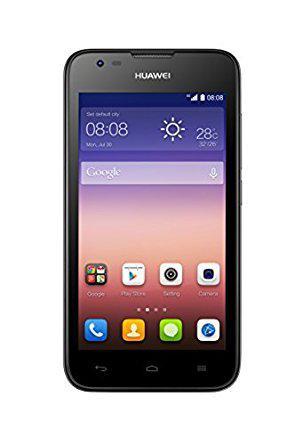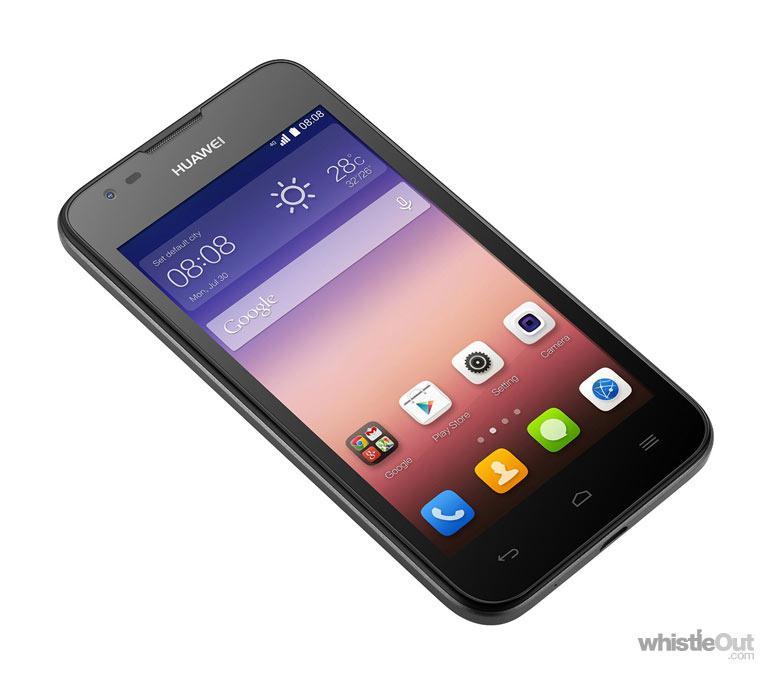The first image is the image on the left, the second image is the image on the right. Evaluate the accuracy of this statement regarding the images: "One image shows the front and the back of a smartphone and the other shows only the front of a smartphone.". Is it true? Answer yes or no. No. The first image is the image on the left, the second image is the image on the right. Evaluate the accuracy of this statement regarding the images: "The left image shows a phone screen side-up that is on the right and overlapping a back-turned phone, and the right image shows only a phone's screen side.". Is it true? Answer yes or no. No. 